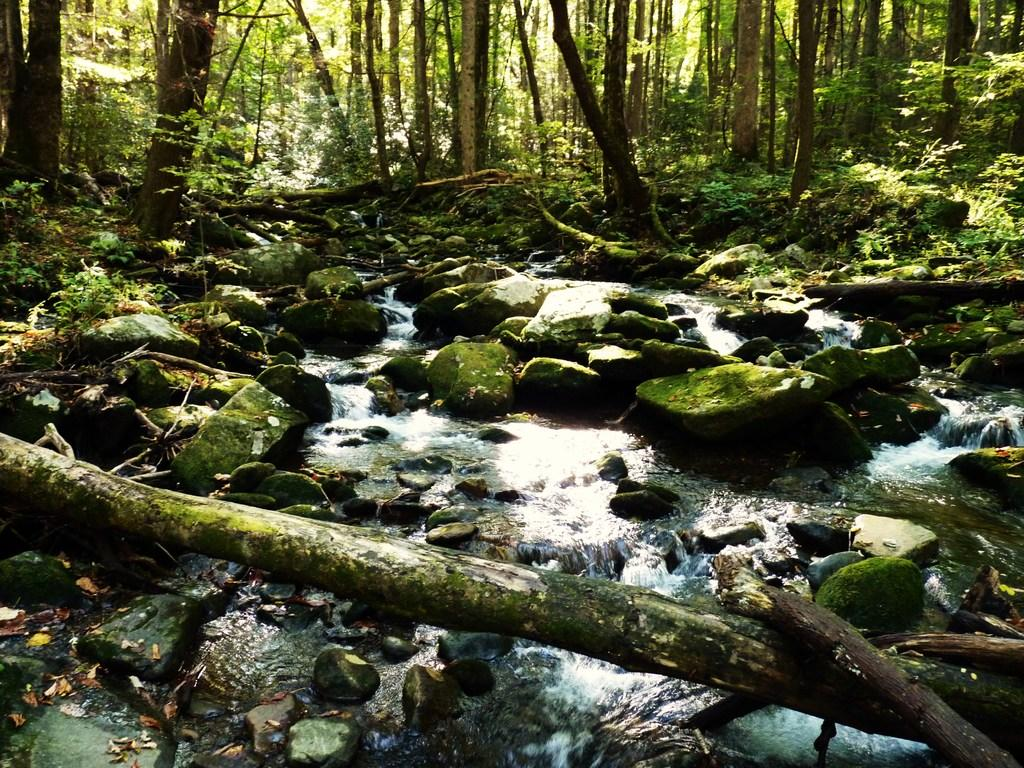What type of vegetation can be seen in the image? There are trees in the image. What is the color of the trees in the image? The trees are green in color. What else is present in the image besides the trees? There is flowing water and stones visible in the image. Where is the desk located in the image? There is no desk present in the image. What type of event is taking place in the image? There is no event depicted in the image; it features trees, flowing water, and stones. 